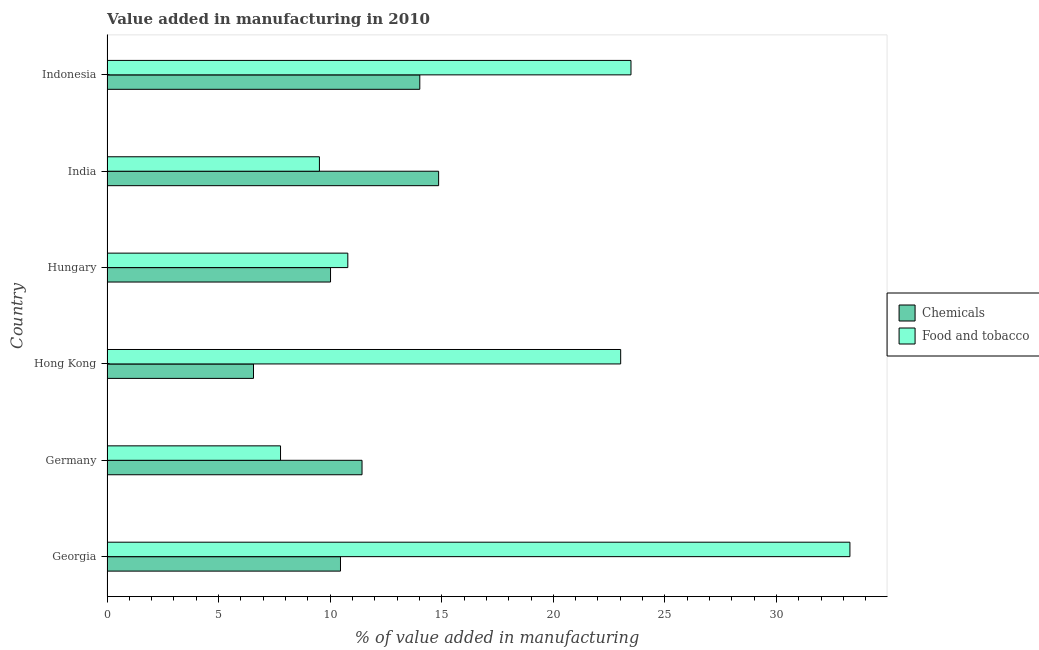Are the number of bars on each tick of the Y-axis equal?
Keep it short and to the point. Yes. How many bars are there on the 1st tick from the bottom?
Offer a terse response. 2. What is the label of the 6th group of bars from the top?
Provide a short and direct response. Georgia. In how many cases, is the number of bars for a given country not equal to the number of legend labels?
Your answer should be compact. 0. What is the value added by  manufacturing chemicals in Indonesia?
Offer a very short reply. 14.02. Across all countries, what is the maximum value added by  manufacturing chemicals?
Provide a short and direct response. 14.86. Across all countries, what is the minimum value added by manufacturing food and tobacco?
Your answer should be very brief. 7.78. In which country was the value added by manufacturing food and tobacco maximum?
Offer a very short reply. Georgia. In which country was the value added by  manufacturing chemicals minimum?
Offer a terse response. Hong Kong. What is the total value added by  manufacturing chemicals in the graph?
Your response must be concise. 67.35. What is the difference between the value added by manufacturing food and tobacco in Hungary and that in Indonesia?
Offer a very short reply. -12.69. What is the difference between the value added by manufacturing food and tobacco in Hong Kong and the value added by  manufacturing chemicals in Germany?
Give a very brief answer. 11.59. What is the average value added by manufacturing food and tobacco per country?
Offer a very short reply. 17.98. What is the difference between the value added by  manufacturing chemicals and value added by manufacturing food and tobacco in India?
Offer a terse response. 5.34. In how many countries, is the value added by  manufacturing chemicals greater than 8 %?
Ensure brevity in your answer.  5. What is the ratio of the value added by  manufacturing chemicals in Germany to that in Hong Kong?
Offer a terse response. 1.74. What is the difference between the highest and the second highest value added by  manufacturing chemicals?
Ensure brevity in your answer.  0.84. What is the difference between the highest and the lowest value added by manufacturing food and tobacco?
Ensure brevity in your answer.  25.51. What does the 1st bar from the top in Indonesia represents?
Provide a short and direct response. Food and tobacco. What does the 2nd bar from the bottom in Germany represents?
Your answer should be compact. Food and tobacco. How many bars are there?
Provide a succinct answer. 12. Are all the bars in the graph horizontal?
Provide a short and direct response. Yes. Does the graph contain any zero values?
Your response must be concise. No. Does the graph contain grids?
Provide a succinct answer. No. How are the legend labels stacked?
Provide a succinct answer. Vertical. What is the title of the graph?
Your response must be concise. Value added in manufacturing in 2010. Does "Public funds" appear as one of the legend labels in the graph?
Give a very brief answer. No. What is the label or title of the X-axis?
Provide a succinct answer. % of value added in manufacturing. What is the % of value added in manufacturing in Chemicals in Georgia?
Offer a terse response. 10.46. What is the % of value added in manufacturing in Food and tobacco in Georgia?
Your answer should be very brief. 33.29. What is the % of value added in manufacturing in Chemicals in Germany?
Keep it short and to the point. 11.43. What is the % of value added in manufacturing in Food and tobacco in Germany?
Your answer should be compact. 7.78. What is the % of value added in manufacturing in Chemicals in Hong Kong?
Offer a terse response. 6.56. What is the % of value added in manufacturing of Food and tobacco in Hong Kong?
Provide a short and direct response. 23.02. What is the % of value added in manufacturing of Chemicals in Hungary?
Offer a very short reply. 10.02. What is the % of value added in manufacturing of Food and tobacco in Hungary?
Provide a short and direct response. 10.79. What is the % of value added in manufacturing of Chemicals in India?
Provide a short and direct response. 14.86. What is the % of value added in manufacturing in Food and tobacco in India?
Provide a succinct answer. 9.52. What is the % of value added in manufacturing of Chemicals in Indonesia?
Give a very brief answer. 14.02. What is the % of value added in manufacturing of Food and tobacco in Indonesia?
Offer a very short reply. 23.48. Across all countries, what is the maximum % of value added in manufacturing of Chemicals?
Provide a short and direct response. 14.86. Across all countries, what is the maximum % of value added in manufacturing of Food and tobacco?
Provide a succinct answer. 33.29. Across all countries, what is the minimum % of value added in manufacturing of Chemicals?
Provide a short and direct response. 6.56. Across all countries, what is the minimum % of value added in manufacturing in Food and tobacco?
Make the answer very short. 7.78. What is the total % of value added in manufacturing in Chemicals in the graph?
Your response must be concise. 67.35. What is the total % of value added in manufacturing in Food and tobacco in the graph?
Your answer should be compact. 107.87. What is the difference between the % of value added in manufacturing of Chemicals in Georgia and that in Germany?
Offer a terse response. -0.97. What is the difference between the % of value added in manufacturing in Food and tobacco in Georgia and that in Germany?
Offer a terse response. 25.51. What is the difference between the % of value added in manufacturing of Chemicals in Georgia and that in Hong Kong?
Provide a short and direct response. 3.9. What is the difference between the % of value added in manufacturing of Food and tobacco in Georgia and that in Hong Kong?
Make the answer very short. 10.27. What is the difference between the % of value added in manufacturing of Chemicals in Georgia and that in Hungary?
Give a very brief answer. 0.45. What is the difference between the % of value added in manufacturing of Food and tobacco in Georgia and that in Hungary?
Your answer should be very brief. 22.5. What is the difference between the % of value added in manufacturing in Chemicals in Georgia and that in India?
Keep it short and to the point. -4.4. What is the difference between the % of value added in manufacturing of Food and tobacco in Georgia and that in India?
Provide a short and direct response. 23.77. What is the difference between the % of value added in manufacturing in Chemicals in Georgia and that in Indonesia?
Ensure brevity in your answer.  -3.55. What is the difference between the % of value added in manufacturing of Food and tobacco in Georgia and that in Indonesia?
Your answer should be compact. 9.81. What is the difference between the % of value added in manufacturing in Chemicals in Germany and that in Hong Kong?
Keep it short and to the point. 4.86. What is the difference between the % of value added in manufacturing in Food and tobacco in Germany and that in Hong Kong?
Offer a very short reply. -15.24. What is the difference between the % of value added in manufacturing in Chemicals in Germany and that in Hungary?
Offer a terse response. 1.41. What is the difference between the % of value added in manufacturing in Food and tobacco in Germany and that in Hungary?
Ensure brevity in your answer.  -3.02. What is the difference between the % of value added in manufacturing of Chemicals in Germany and that in India?
Your answer should be very brief. -3.43. What is the difference between the % of value added in manufacturing in Food and tobacco in Germany and that in India?
Keep it short and to the point. -1.74. What is the difference between the % of value added in manufacturing in Chemicals in Germany and that in Indonesia?
Offer a very short reply. -2.59. What is the difference between the % of value added in manufacturing of Food and tobacco in Germany and that in Indonesia?
Provide a short and direct response. -15.7. What is the difference between the % of value added in manufacturing in Chemicals in Hong Kong and that in Hungary?
Make the answer very short. -3.45. What is the difference between the % of value added in manufacturing in Food and tobacco in Hong Kong and that in Hungary?
Ensure brevity in your answer.  12.23. What is the difference between the % of value added in manufacturing of Chemicals in Hong Kong and that in India?
Provide a short and direct response. -8.3. What is the difference between the % of value added in manufacturing of Food and tobacco in Hong Kong and that in India?
Provide a succinct answer. 13.5. What is the difference between the % of value added in manufacturing of Chemicals in Hong Kong and that in Indonesia?
Give a very brief answer. -7.45. What is the difference between the % of value added in manufacturing in Food and tobacco in Hong Kong and that in Indonesia?
Your answer should be very brief. -0.46. What is the difference between the % of value added in manufacturing of Chemicals in Hungary and that in India?
Offer a very short reply. -4.84. What is the difference between the % of value added in manufacturing in Food and tobacco in Hungary and that in India?
Offer a terse response. 1.27. What is the difference between the % of value added in manufacturing in Chemicals in Hungary and that in Indonesia?
Give a very brief answer. -4. What is the difference between the % of value added in manufacturing of Food and tobacco in Hungary and that in Indonesia?
Your answer should be very brief. -12.69. What is the difference between the % of value added in manufacturing of Chemicals in India and that in Indonesia?
Your answer should be compact. 0.84. What is the difference between the % of value added in manufacturing of Food and tobacco in India and that in Indonesia?
Your answer should be compact. -13.96. What is the difference between the % of value added in manufacturing in Chemicals in Georgia and the % of value added in manufacturing in Food and tobacco in Germany?
Your answer should be very brief. 2.69. What is the difference between the % of value added in manufacturing in Chemicals in Georgia and the % of value added in manufacturing in Food and tobacco in Hong Kong?
Make the answer very short. -12.55. What is the difference between the % of value added in manufacturing of Chemicals in Georgia and the % of value added in manufacturing of Food and tobacco in Hungary?
Provide a succinct answer. -0.33. What is the difference between the % of value added in manufacturing of Chemicals in Georgia and the % of value added in manufacturing of Food and tobacco in India?
Your answer should be compact. 0.94. What is the difference between the % of value added in manufacturing in Chemicals in Georgia and the % of value added in manufacturing in Food and tobacco in Indonesia?
Your response must be concise. -13.02. What is the difference between the % of value added in manufacturing in Chemicals in Germany and the % of value added in manufacturing in Food and tobacco in Hong Kong?
Provide a succinct answer. -11.59. What is the difference between the % of value added in manufacturing of Chemicals in Germany and the % of value added in manufacturing of Food and tobacco in Hungary?
Give a very brief answer. 0.64. What is the difference between the % of value added in manufacturing in Chemicals in Germany and the % of value added in manufacturing in Food and tobacco in India?
Make the answer very short. 1.91. What is the difference between the % of value added in manufacturing of Chemicals in Germany and the % of value added in manufacturing of Food and tobacco in Indonesia?
Give a very brief answer. -12.05. What is the difference between the % of value added in manufacturing in Chemicals in Hong Kong and the % of value added in manufacturing in Food and tobacco in Hungary?
Provide a succinct answer. -4.23. What is the difference between the % of value added in manufacturing of Chemicals in Hong Kong and the % of value added in manufacturing of Food and tobacco in India?
Provide a short and direct response. -2.95. What is the difference between the % of value added in manufacturing in Chemicals in Hong Kong and the % of value added in manufacturing in Food and tobacco in Indonesia?
Give a very brief answer. -16.91. What is the difference between the % of value added in manufacturing in Chemicals in Hungary and the % of value added in manufacturing in Food and tobacco in India?
Ensure brevity in your answer.  0.5. What is the difference between the % of value added in manufacturing of Chemicals in Hungary and the % of value added in manufacturing of Food and tobacco in Indonesia?
Offer a very short reply. -13.46. What is the difference between the % of value added in manufacturing in Chemicals in India and the % of value added in manufacturing in Food and tobacco in Indonesia?
Provide a succinct answer. -8.62. What is the average % of value added in manufacturing of Chemicals per country?
Provide a short and direct response. 11.22. What is the average % of value added in manufacturing in Food and tobacco per country?
Your answer should be very brief. 17.98. What is the difference between the % of value added in manufacturing in Chemicals and % of value added in manufacturing in Food and tobacco in Georgia?
Your answer should be compact. -22.83. What is the difference between the % of value added in manufacturing in Chemicals and % of value added in manufacturing in Food and tobacco in Germany?
Provide a short and direct response. 3.65. What is the difference between the % of value added in manufacturing in Chemicals and % of value added in manufacturing in Food and tobacco in Hong Kong?
Your answer should be compact. -16.45. What is the difference between the % of value added in manufacturing of Chemicals and % of value added in manufacturing of Food and tobacco in Hungary?
Ensure brevity in your answer.  -0.77. What is the difference between the % of value added in manufacturing in Chemicals and % of value added in manufacturing in Food and tobacco in India?
Provide a short and direct response. 5.34. What is the difference between the % of value added in manufacturing of Chemicals and % of value added in manufacturing of Food and tobacco in Indonesia?
Offer a very short reply. -9.46. What is the ratio of the % of value added in manufacturing of Chemicals in Georgia to that in Germany?
Keep it short and to the point. 0.92. What is the ratio of the % of value added in manufacturing in Food and tobacco in Georgia to that in Germany?
Keep it short and to the point. 4.28. What is the ratio of the % of value added in manufacturing in Chemicals in Georgia to that in Hong Kong?
Provide a short and direct response. 1.59. What is the ratio of the % of value added in manufacturing in Food and tobacco in Georgia to that in Hong Kong?
Make the answer very short. 1.45. What is the ratio of the % of value added in manufacturing of Chemicals in Georgia to that in Hungary?
Ensure brevity in your answer.  1.04. What is the ratio of the % of value added in manufacturing of Food and tobacco in Georgia to that in Hungary?
Provide a succinct answer. 3.08. What is the ratio of the % of value added in manufacturing in Chemicals in Georgia to that in India?
Offer a very short reply. 0.7. What is the ratio of the % of value added in manufacturing of Food and tobacco in Georgia to that in India?
Offer a terse response. 3.5. What is the ratio of the % of value added in manufacturing in Chemicals in Georgia to that in Indonesia?
Keep it short and to the point. 0.75. What is the ratio of the % of value added in manufacturing in Food and tobacco in Georgia to that in Indonesia?
Provide a succinct answer. 1.42. What is the ratio of the % of value added in manufacturing in Chemicals in Germany to that in Hong Kong?
Your answer should be very brief. 1.74. What is the ratio of the % of value added in manufacturing in Food and tobacco in Germany to that in Hong Kong?
Ensure brevity in your answer.  0.34. What is the ratio of the % of value added in manufacturing of Chemicals in Germany to that in Hungary?
Provide a short and direct response. 1.14. What is the ratio of the % of value added in manufacturing of Food and tobacco in Germany to that in Hungary?
Ensure brevity in your answer.  0.72. What is the ratio of the % of value added in manufacturing in Chemicals in Germany to that in India?
Give a very brief answer. 0.77. What is the ratio of the % of value added in manufacturing in Food and tobacco in Germany to that in India?
Your answer should be very brief. 0.82. What is the ratio of the % of value added in manufacturing in Chemicals in Germany to that in Indonesia?
Your answer should be compact. 0.82. What is the ratio of the % of value added in manufacturing of Food and tobacco in Germany to that in Indonesia?
Make the answer very short. 0.33. What is the ratio of the % of value added in manufacturing of Chemicals in Hong Kong to that in Hungary?
Provide a short and direct response. 0.66. What is the ratio of the % of value added in manufacturing of Food and tobacco in Hong Kong to that in Hungary?
Keep it short and to the point. 2.13. What is the ratio of the % of value added in manufacturing in Chemicals in Hong Kong to that in India?
Ensure brevity in your answer.  0.44. What is the ratio of the % of value added in manufacturing of Food and tobacco in Hong Kong to that in India?
Your answer should be very brief. 2.42. What is the ratio of the % of value added in manufacturing in Chemicals in Hong Kong to that in Indonesia?
Give a very brief answer. 0.47. What is the ratio of the % of value added in manufacturing of Food and tobacco in Hong Kong to that in Indonesia?
Your answer should be compact. 0.98. What is the ratio of the % of value added in manufacturing of Chemicals in Hungary to that in India?
Your answer should be very brief. 0.67. What is the ratio of the % of value added in manufacturing of Food and tobacco in Hungary to that in India?
Offer a very short reply. 1.13. What is the ratio of the % of value added in manufacturing in Chemicals in Hungary to that in Indonesia?
Your answer should be very brief. 0.71. What is the ratio of the % of value added in manufacturing in Food and tobacco in Hungary to that in Indonesia?
Offer a terse response. 0.46. What is the ratio of the % of value added in manufacturing of Chemicals in India to that in Indonesia?
Your response must be concise. 1.06. What is the ratio of the % of value added in manufacturing of Food and tobacco in India to that in Indonesia?
Keep it short and to the point. 0.41. What is the difference between the highest and the second highest % of value added in manufacturing of Chemicals?
Offer a terse response. 0.84. What is the difference between the highest and the second highest % of value added in manufacturing in Food and tobacco?
Offer a very short reply. 9.81. What is the difference between the highest and the lowest % of value added in manufacturing of Chemicals?
Offer a terse response. 8.3. What is the difference between the highest and the lowest % of value added in manufacturing of Food and tobacco?
Your answer should be very brief. 25.51. 